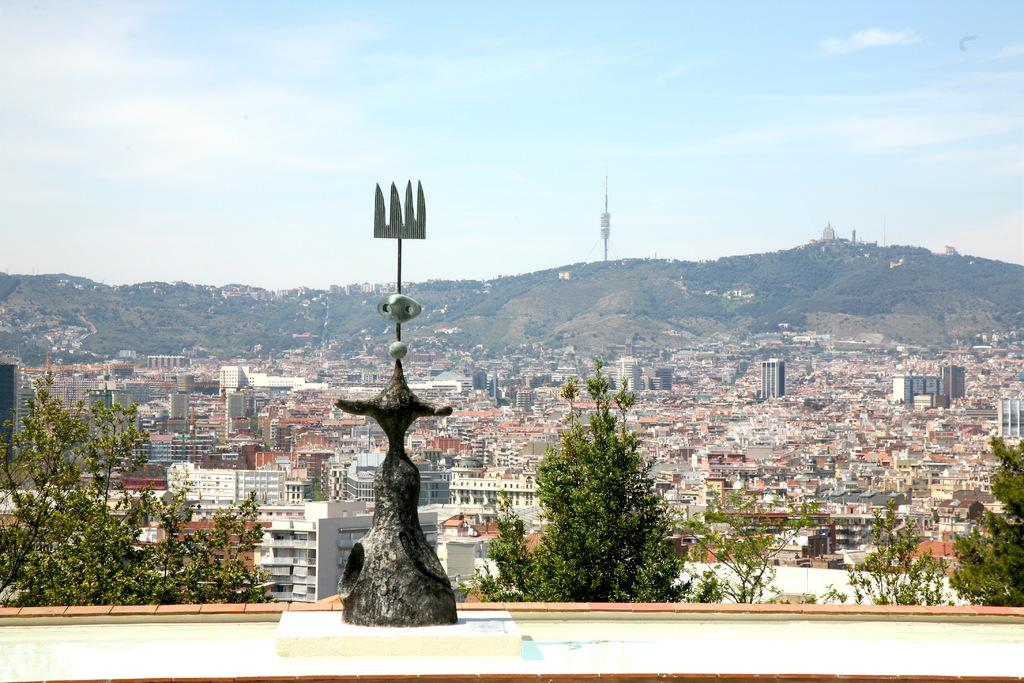What type of sculpture is in the image? There is a bronze sculpture in the image. What other natural elements can be seen in the image? There are trees in the image. What man-made structures are present in the image? There are buildings in the image. What geographical feature is visible in the image? There is a mountain in the image. What is visible in the background of the image? The sky is visible in the background of the image. What type of horn is being played by the governor in the image? There is no governor or horn present in the image. 